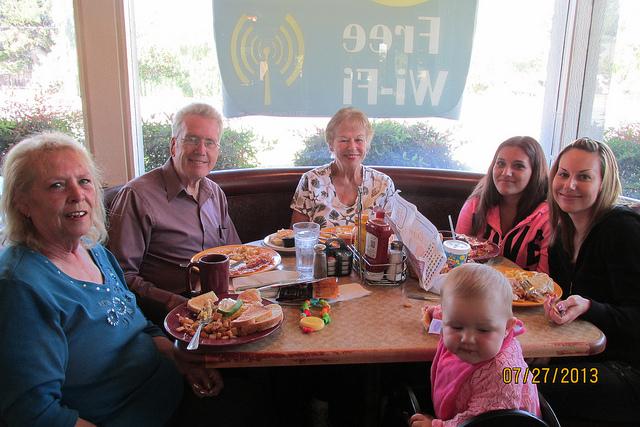What color are the people's hair?
Give a very brief answer. Blonde, brown. Are these people posing for a picture?
Answer briefly. Yes. Is the baby a girl?
Give a very brief answer. Yes. Are these people eating?
Quick response, please. Yes. 